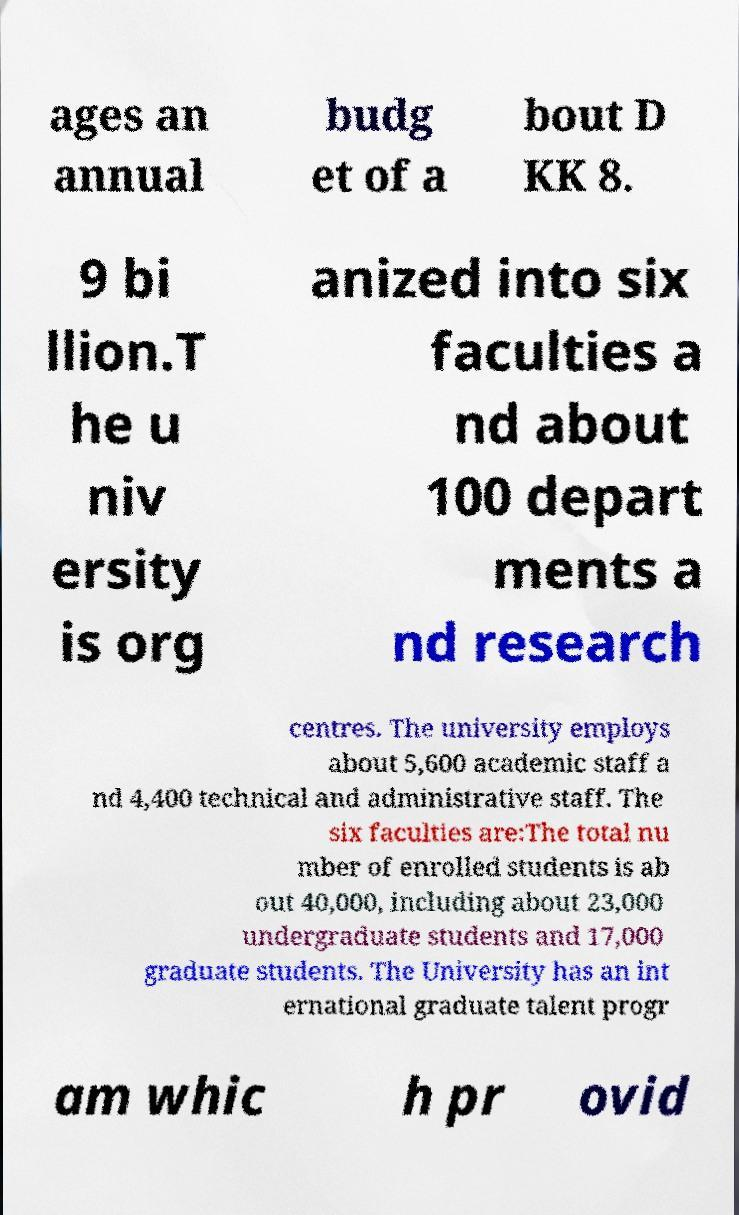Could you extract and type out the text from this image? ages an annual budg et of a bout D KK 8. 9 bi llion.T he u niv ersity is org anized into six faculties a nd about 100 depart ments a nd research centres. The university employs about 5,600 academic staff a nd 4,400 technical and administrative staff. The six faculties are:The total nu mber of enrolled students is ab out 40,000, including about 23,000 undergraduate students and 17,000 graduate students. The University has an int ernational graduate talent progr am whic h pr ovid 